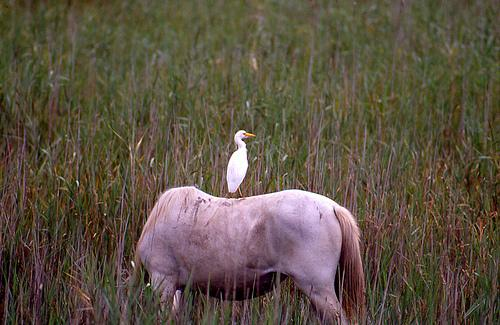Question: what is tan?
Choices:
A. House.
B. Goat.
C. Horse.
D. Cow.
Answer with the letter. Answer: C Question: what is in the background?
Choices:
A. Trees.
B. Grass.
C. Ocean.
D. Mountains.
Answer with the letter. Answer: B Question: what color is the grass?
Choices:
A. Orange.
B. Blue.
C. Green.
D. Red.
Answer with the letter. Answer: C 